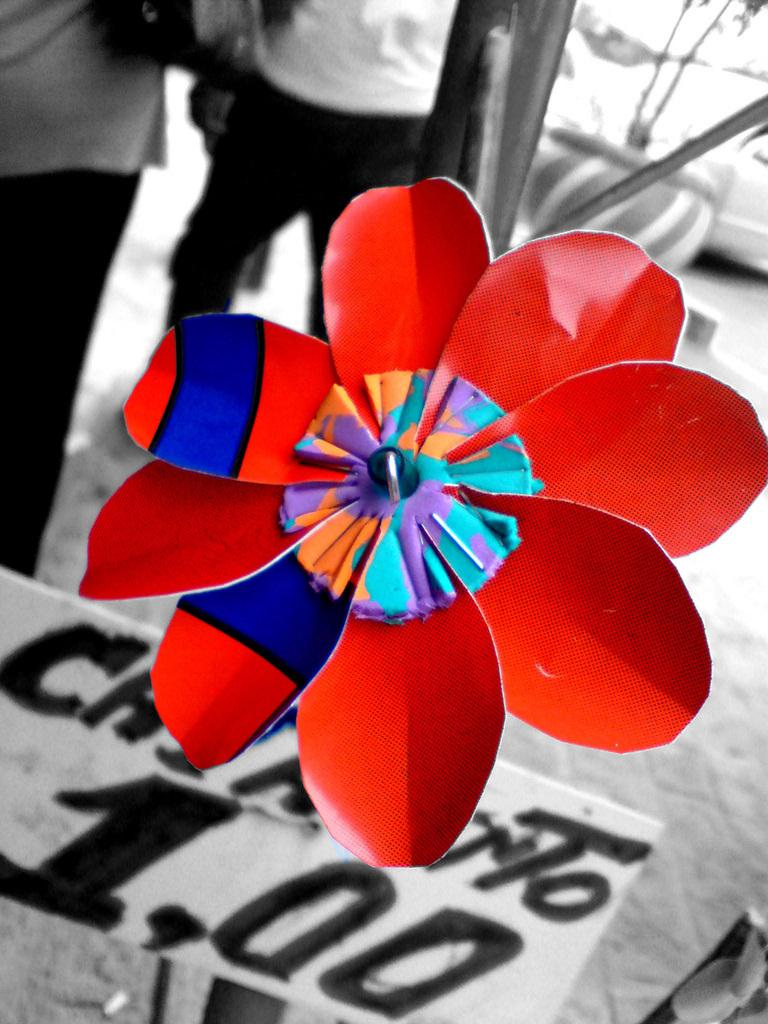What is the main subject in the center of the image? There is a craft in the center of the image. What is located at the bottom of the image? There is a board at the bottom of the image. Can you describe the background of the image? There are people visible in the background of the image. What type of fish can be seen swimming in the park in the image? There is no fish or park present in the image; it features a craft and a board with people in the background. 